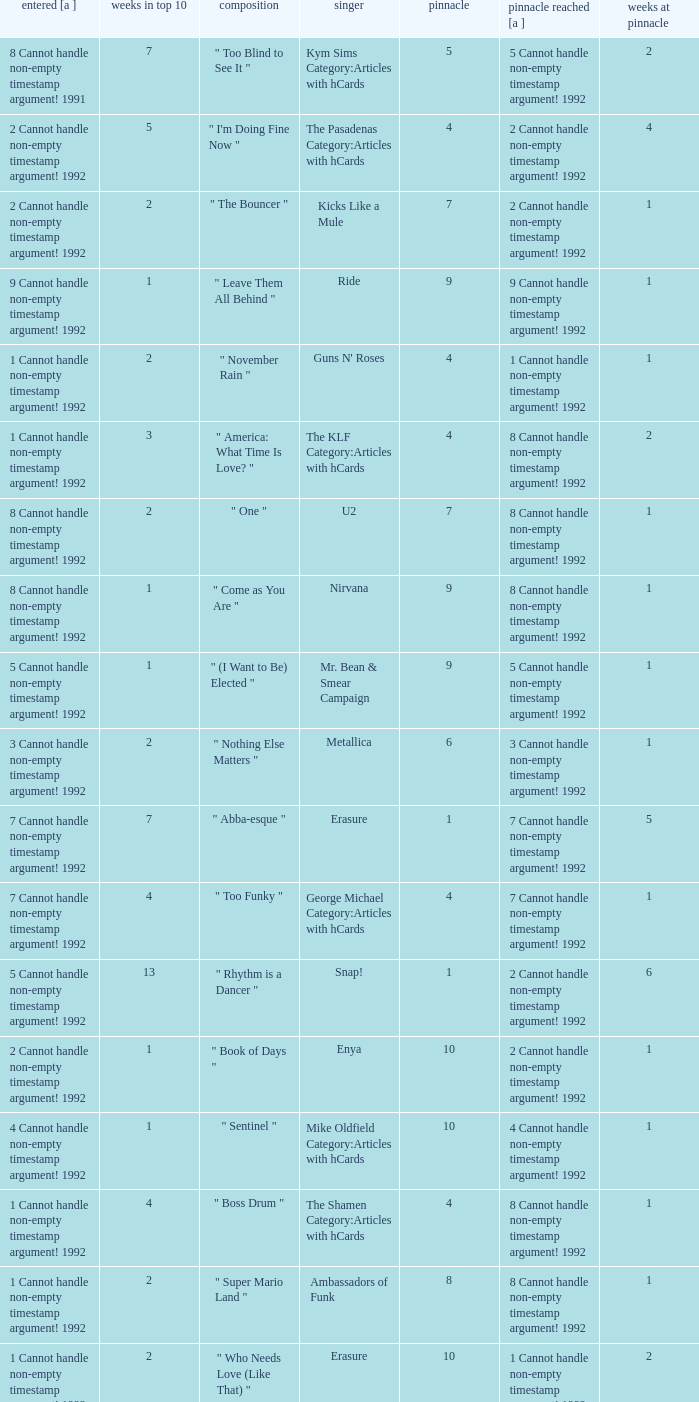If the peak reached is 6 cannot handle non-empty timestamp argument! 1992, what is the entered? 6 Cannot handle non-empty timestamp argument! 1992. 